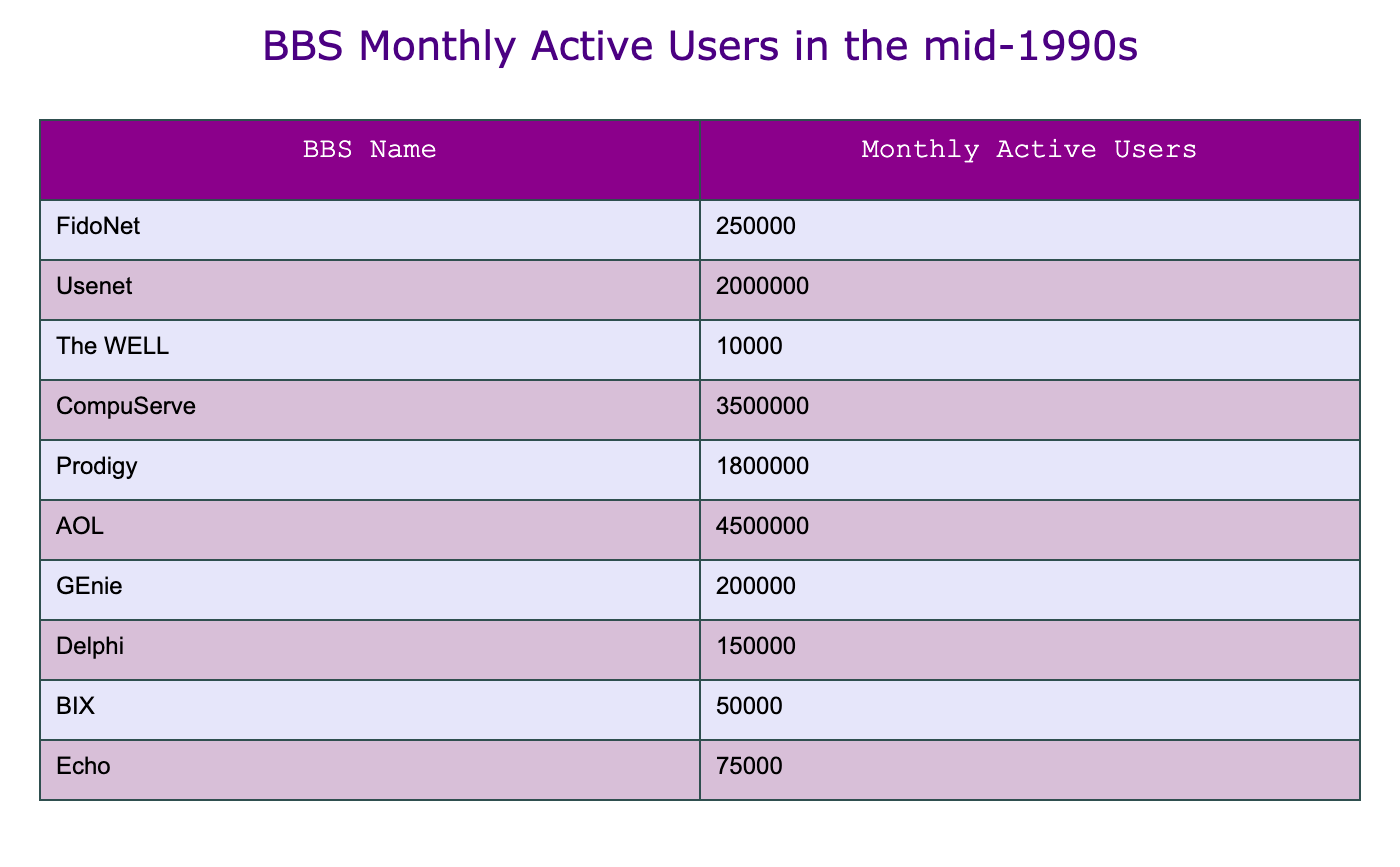What BBS system had the highest monthly active users? By reviewing the table, we can identify that AOL has the value of 4,500,000 monthly active users, which is the highest among all the listed BBS systems.
Answer: AOL What is the number of monthly active users for Compuserve? The table shows that CompuServe has 3,500,000 monthly active users.
Answer: 3,500,000 How many BBS systems had more than 100,000 monthly active users? By examining the table, we find that the BBS systems with more than 100,000 monthly active users are Usenet, CompuServe, Prodigy, and AOL. Counting them gives us a total of four systems.
Answer: 4 Which BBS system had the fewest monthly active users? From the table, The WELL has the lowest number of monthly active users with a count of 10,000.
Answer: The WELL What is the difference in monthly active users between AOL and The WELL? To find this difference, we subtract The WELL's users (10,000) from AOL's (4,500,000), giving us 4,500,000 - 10,000 = 4,490,000.
Answer: 4,490,000 Is it true that GEnie had more monthly active users than Delphi? By checking the values in the table, GEnie had 200,000 users while Delphi had 150,000 users. Since 200,000 is greater than 150,000, the statement is true.
Answer: True What is the total number of monthly active users across all BBS systems? To calculate the total, we sum all the monthly active users: 250,000 (FidoNet) + 2,000,000 (Usenet) + 10,000 (The WELL) + 3,500,000 (CompuServe) + 1,800,000 (Prodigy) + 4,500,000 (AOL) + 200,000 (GEnie) + 150,000 (Delphi) + 50,000 (BIX) + 75,000 (Echo) = 12,535,000.
Answer: 12,535,000 Which BBS systems had less than 100,000 monthly active users? From the table, the BBS systems with less than 100,000 users are The WELL (10,000), BIX (50,000), and Echo (75,000). There are three systems in this category.
Answer: 3 What is the average number of monthly active users of the listed BBS systems? To find the average, we sum the monthly active users (12,535,000) and divide by the number of systems (10). So we calculate: 12,535,000 / 10 = 1,253,500.
Answer: 1,253,500 